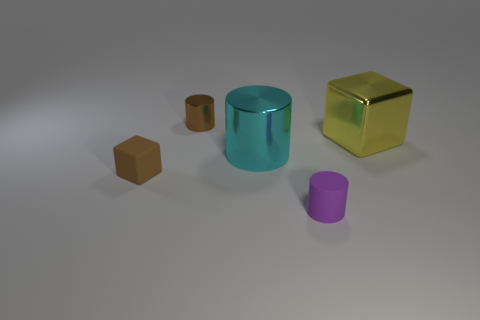How many objects are there in the image, and can you categorize them by shape? There are five objects in the image. They can be categorized by shape into two cubes, two cylinders, and one rectangular prism. 